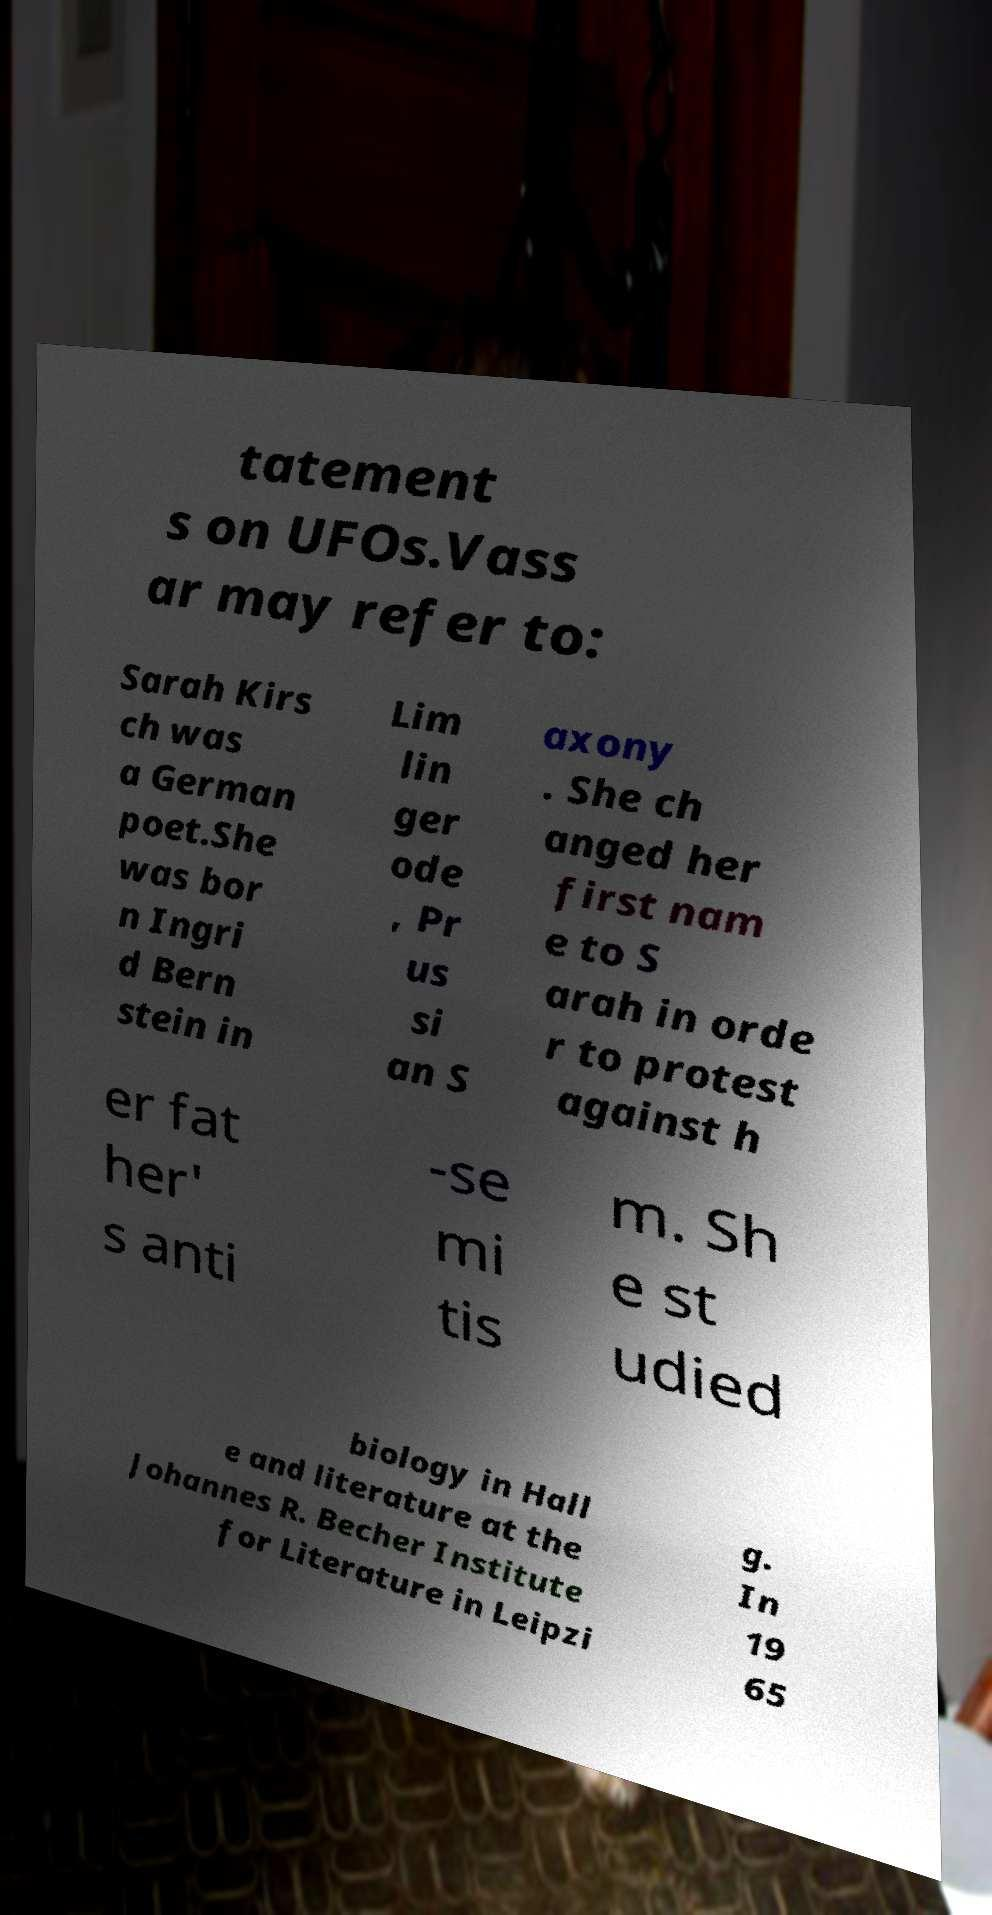Can you accurately transcribe the text from the provided image for me? tatement s on UFOs.Vass ar may refer to: Sarah Kirs ch was a German poet.She was bor n Ingri d Bern stein in Lim lin ger ode , Pr us si an S axony . She ch anged her first nam e to S arah in orde r to protest against h er fat her' s anti -se mi tis m. Sh e st udied biology in Hall e and literature at the Johannes R. Becher Institute for Literature in Leipzi g. In 19 65 